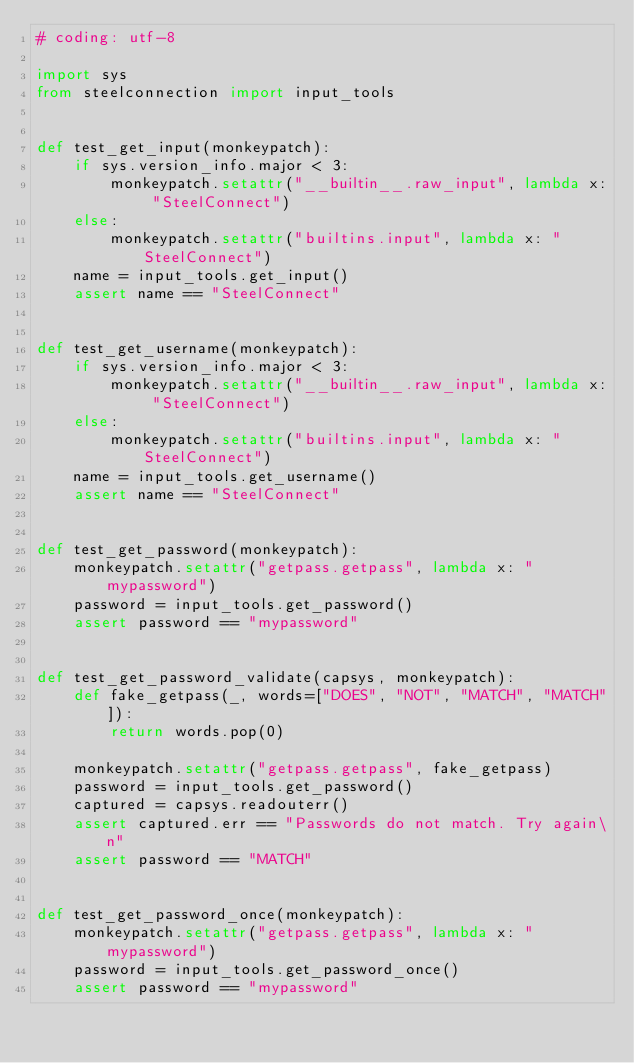<code> <loc_0><loc_0><loc_500><loc_500><_Python_># coding: utf-8

import sys
from steelconnection import input_tools


def test_get_input(monkeypatch):
    if sys.version_info.major < 3:
        monkeypatch.setattr("__builtin__.raw_input", lambda x: "SteelConnect")
    else:
        monkeypatch.setattr("builtins.input", lambda x: "SteelConnect")
    name = input_tools.get_input()
    assert name == "SteelConnect"


def test_get_username(monkeypatch):
    if sys.version_info.major < 3:
        monkeypatch.setattr("__builtin__.raw_input", lambda x: "SteelConnect")
    else:
        monkeypatch.setattr("builtins.input", lambda x: "SteelConnect")
    name = input_tools.get_username()
    assert name == "SteelConnect"


def test_get_password(monkeypatch):
    monkeypatch.setattr("getpass.getpass", lambda x: "mypassword")
    password = input_tools.get_password()
    assert password == "mypassword"


def test_get_password_validate(capsys, monkeypatch):
    def fake_getpass(_, words=["DOES", "NOT", "MATCH", "MATCH"]):
        return words.pop(0)

    monkeypatch.setattr("getpass.getpass", fake_getpass)
    password = input_tools.get_password()
    captured = capsys.readouterr()
    assert captured.err == "Passwords do not match. Try again\n"
    assert password == "MATCH"


def test_get_password_once(monkeypatch):
    monkeypatch.setattr("getpass.getpass", lambda x: "mypassword")
    password = input_tools.get_password_once()
    assert password == "mypassword"
</code> 